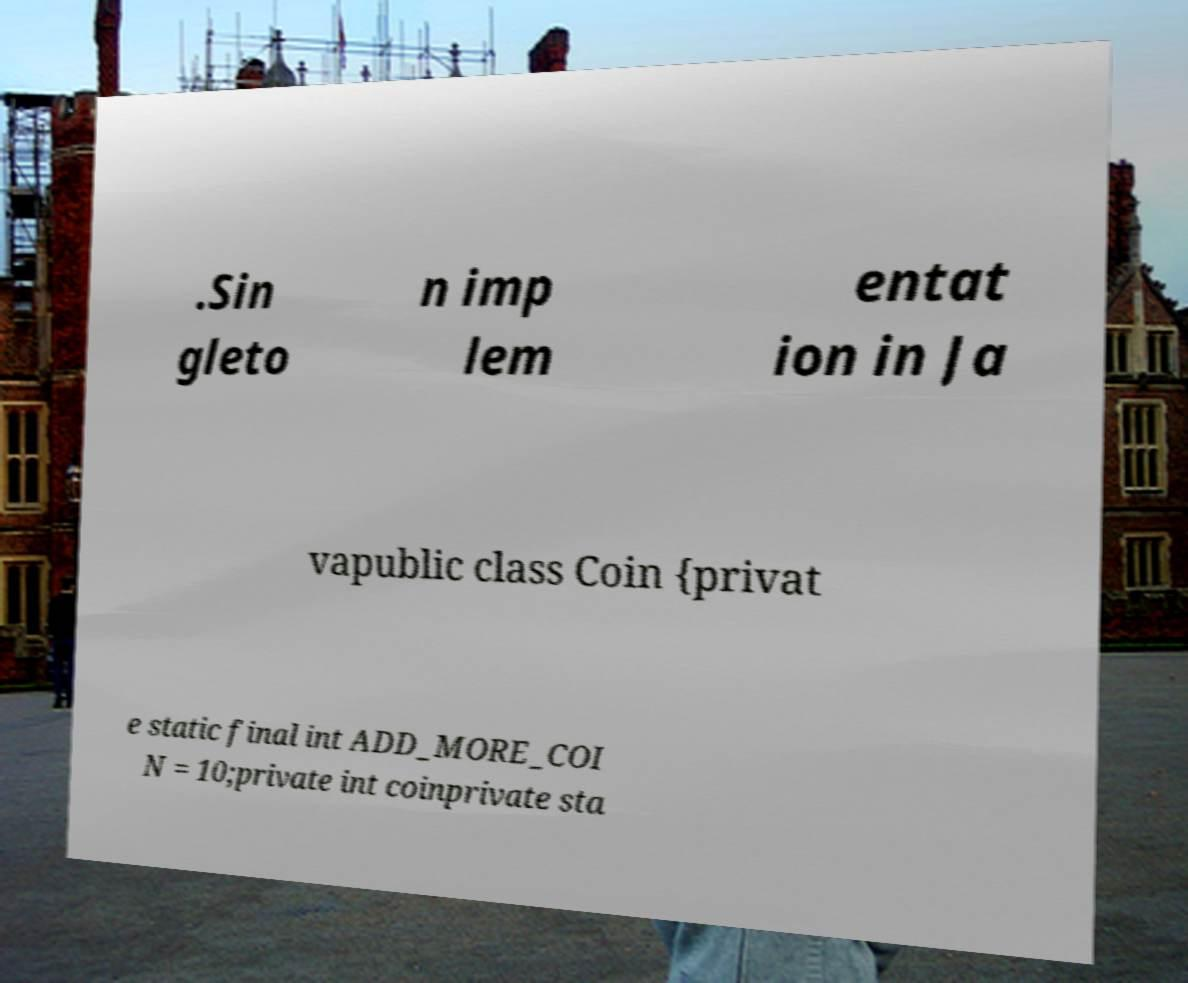Could you assist in decoding the text presented in this image and type it out clearly? .Sin gleto n imp lem entat ion in Ja vapublic class Coin {privat e static final int ADD_MORE_COI N = 10;private int coinprivate sta 